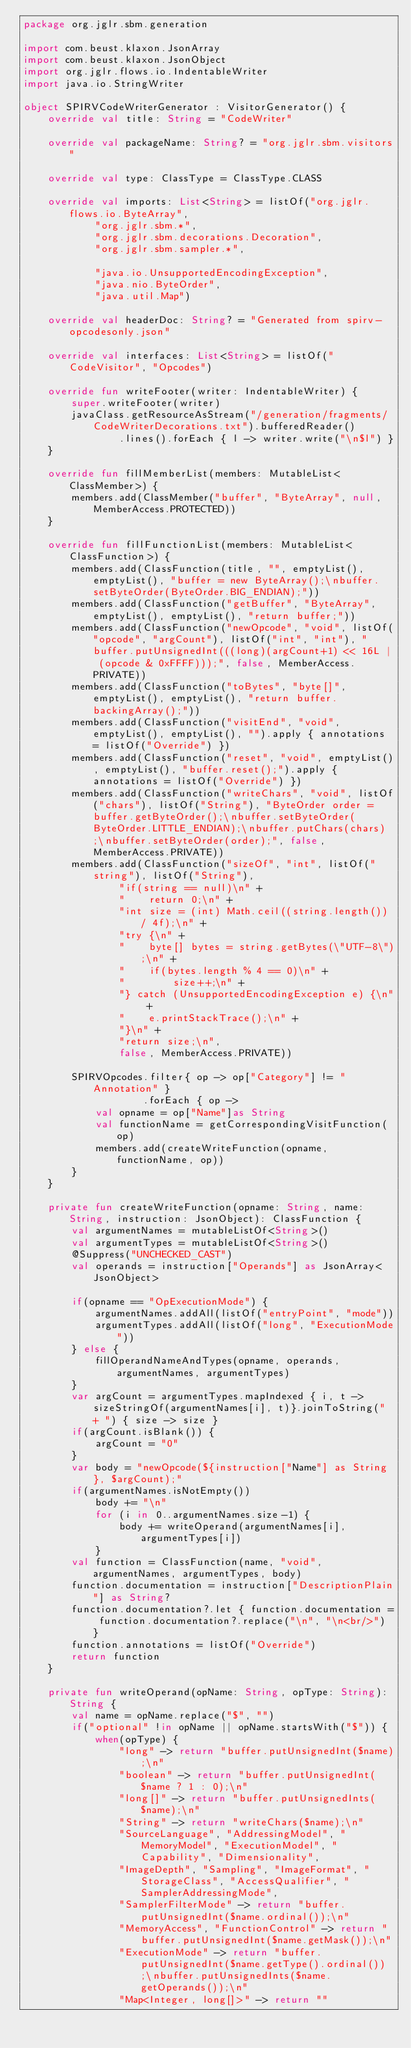<code> <loc_0><loc_0><loc_500><loc_500><_Kotlin_>package org.jglr.sbm.generation

import com.beust.klaxon.JsonArray
import com.beust.klaxon.JsonObject
import org.jglr.flows.io.IndentableWriter
import java.io.StringWriter

object SPIRVCodeWriterGenerator : VisitorGenerator() {
    override val title: String = "CodeWriter"

    override val packageName: String? = "org.jglr.sbm.visitors"

    override val type: ClassType = ClassType.CLASS

    override val imports: List<String> = listOf("org.jglr.flows.io.ByteArray",
            "org.jglr.sbm.*",
            "org.jglr.sbm.decorations.Decoration",
            "org.jglr.sbm.sampler.*",

            "java.io.UnsupportedEncodingException",
            "java.nio.ByteOrder",
            "java.util.Map")

    override val headerDoc: String? = "Generated from spirv-opcodesonly.json"

    override val interfaces: List<String> = listOf("CodeVisitor", "Opcodes")

    override fun writeFooter(writer: IndentableWriter) {
        super.writeFooter(writer)
        javaClass.getResourceAsStream("/generation/fragments/CodeWriterDecorations.txt").bufferedReader()
                .lines().forEach { l -> writer.write("\n$l") }
    }

    override fun fillMemberList(members: MutableList<ClassMember>) {
        members.add(ClassMember("buffer", "ByteArray", null, MemberAccess.PROTECTED))
    }

    override fun fillFunctionList(members: MutableList<ClassFunction>) {
        members.add(ClassFunction(title, "", emptyList(), emptyList(), "buffer = new ByteArray();\nbuffer.setByteOrder(ByteOrder.BIG_ENDIAN);"))
        members.add(ClassFunction("getBuffer", "ByteArray", emptyList(), emptyList(), "return buffer;"))
        members.add(ClassFunction("newOpcode", "void", listOf("opcode", "argCount"), listOf("int", "int"), "buffer.putUnsignedInt(((long)(argCount+1) << 16L | (opcode & 0xFFFF)));", false, MemberAccess.PRIVATE))
        members.add(ClassFunction("toBytes", "byte[]", emptyList(), emptyList(), "return buffer.backingArray();"))
        members.add(ClassFunction("visitEnd", "void", emptyList(), emptyList(), "").apply { annotations = listOf("Override") })
        members.add(ClassFunction("reset", "void", emptyList(), emptyList(), "buffer.reset();").apply { annotations = listOf("Override") })
        members.add(ClassFunction("writeChars", "void", listOf("chars"), listOf("String"), "ByteOrder order = buffer.getByteOrder();\nbuffer.setByteOrder(ByteOrder.LITTLE_ENDIAN);\nbuffer.putChars(chars);\nbuffer.setByteOrder(order);", false, MemberAccess.PRIVATE))
        members.add(ClassFunction("sizeOf", "int", listOf("string"), listOf("String"),
                "if(string == null)\n" +
                "    return 0;\n" +
                "int size = (int) Math.ceil((string.length()) / 4f);\n" +
                "try {\n" +
                "    byte[] bytes = string.getBytes(\"UTF-8\");\n" +
                "    if(bytes.length % 4 == 0)\n" +
                "        size++;\n" +
                "} catch (UnsupportedEncodingException e) {\n" +
                "    e.printStackTrace();\n" +
                "}\n" +
                "return size;\n",
                false, MemberAccess.PRIVATE))

        SPIRVOpcodes.filter{ op -> op["Category"] != "Annotation" }
                    .forEach { op ->
            val opname = op["Name"]as String
            val functionName = getCorrespondingVisitFunction(op)
            members.add(createWriteFunction(opname, functionName, op))
        }
    }

    private fun createWriteFunction(opname: String, name: String, instruction: JsonObject): ClassFunction {
        val argumentNames = mutableListOf<String>()
        val argumentTypes = mutableListOf<String>()
        @Suppress("UNCHECKED_CAST")
        val operands = instruction["Operands"] as JsonArray<JsonObject>

        if(opname == "OpExecutionMode") {
            argumentNames.addAll(listOf("entryPoint", "mode"))
            argumentTypes.addAll(listOf("long", "ExecutionMode"))
        } else {
            fillOperandNameAndTypes(opname, operands, argumentNames, argumentTypes)
        }
        var argCount = argumentTypes.mapIndexed { i, t -> sizeStringOf(argumentNames[i], t)}.joinToString(" + ") { size -> size }
        if(argCount.isBlank()) {
            argCount = "0"
        }
        var body = "newOpcode(${instruction["Name"] as String}, $argCount);"
        if(argumentNames.isNotEmpty())
            body += "\n"
            for (i in 0..argumentNames.size-1) {
                body += writeOperand(argumentNames[i], argumentTypes[i])
            }
        val function = ClassFunction(name, "void", argumentNames, argumentTypes, body)
        function.documentation = instruction["DescriptionPlain"] as String?
        function.documentation?.let { function.documentation = function.documentation?.replace("\n", "\n<br/>") }
        function.annotations = listOf("Override")
        return function
    }

    private fun writeOperand(opName: String, opType: String): String {
        val name = opName.replace("$", "")
        if("optional" !in opName || opName.startsWith("$")) {
            when(opType) {
                "long" -> return "buffer.putUnsignedInt($name);\n"
                "boolean" -> return "buffer.putUnsignedInt($name ? 1 : 0);\n"
                "long[]" -> return "buffer.putUnsignedInts($name);\n"
                "String" -> return "writeChars($name);\n"
                "SourceLanguage", "AddressingModel", "MemoryModel", "ExecutionModel", "Capability", "Dimensionality",
                "ImageDepth", "Sampling", "ImageFormat", "StorageClass", "AccessQualifier", "SamplerAddressingMode",
                "SamplerFilterMode" -> return "buffer.putUnsignedInt($name.ordinal());\n"
                "MemoryAccess", "FunctionControl" -> return "buffer.putUnsignedInt($name.getMask());\n"
                "ExecutionMode" -> return "buffer.putUnsignedInt($name.getType().ordinal());\nbuffer.putUnsignedInts($name.getOperands());\n"
                "Map<Integer, long[]>" -> return ""</code> 